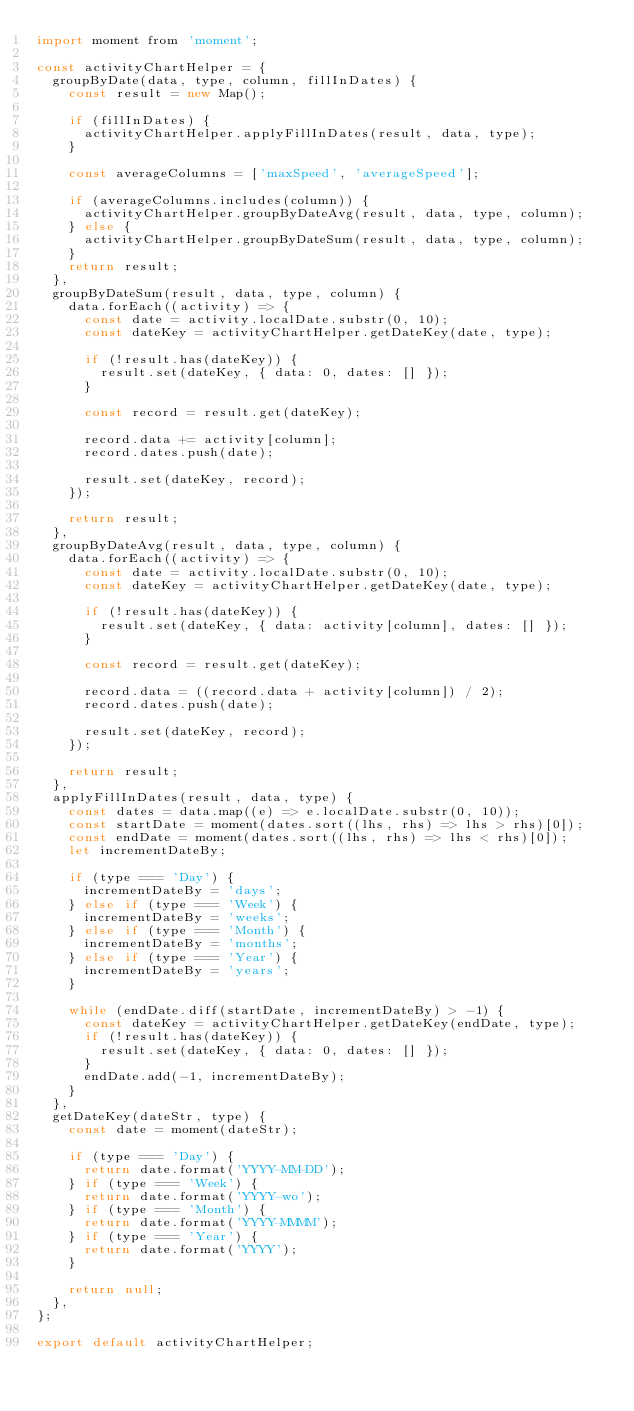Convert code to text. <code><loc_0><loc_0><loc_500><loc_500><_JavaScript_>import moment from 'moment';

const activityChartHelper = {
  groupByDate(data, type, column, fillInDates) {
    const result = new Map();

    if (fillInDates) {
      activityChartHelper.applyFillInDates(result, data, type);
    }

    const averageColumns = ['maxSpeed', 'averageSpeed'];

    if (averageColumns.includes(column)) {
      activityChartHelper.groupByDateAvg(result, data, type, column);
    } else {
      activityChartHelper.groupByDateSum(result, data, type, column);
    }
    return result;
  },
  groupByDateSum(result, data, type, column) {
    data.forEach((activity) => {
      const date = activity.localDate.substr(0, 10);
      const dateKey = activityChartHelper.getDateKey(date, type);

      if (!result.has(dateKey)) {
        result.set(dateKey, { data: 0, dates: [] });
      }

      const record = result.get(dateKey);

      record.data += activity[column];
      record.dates.push(date);

      result.set(dateKey, record);
    });

    return result;
  },
  groupByDateAvg(result, data, type, column) {
    data.forEach((activity) => {
      const date = activity.localDate.substr(0, 10);
      const dateKey = activityChartHelper.getDateKey(date, type);

      if (!result.has(dateKey)) {
        result.set(dateKey, { data: activity[column], dates: [] });
      }

      const record = result.get(dateKey);

      record.data = ((record.data + activity[column]) / 2);
      record.dates.push(date);

      result.set(dateKey, record);
    });

    return result;
  },
  applyFillInDates(result, data, type) {
    const dates = data.map((e) => e.localDate.substr(0, 10));
    const startDate = moment(dates.sort((lhs, rhs) => lhs > rhs)[0]);
    const endDate = moment(dates.sort((lhs, rhs) => lhs < rhs)[0]);
    let incrementDateBy;

    if (type === 'Day') {
      incrementDateBy = 'days';
    } else if (type === 'Week') {
      incrementDateBy = 'weeks';
    } else if (type === 'Month') {
      incrementDateBy = 'months';
    } else if (type === 'Year') {
      incrementDateBy = 'years';
    }

    while (endDate.diff(startDate, incrementDateBy) > -1) {
      const dateKey = activityChartHelper.getDateKey(endDate, type);
      if (!result.has(dateKey)) {
        result.set(dateKey, { data: 0, dates: [] });
      }
      endDate.add(-1, incrementDateBy);
    }
  },
  getDateKey(dateStr, type) {
    const date = moment(dateStr);

    if (type === 'Day') {
      return date.format('YYYY-MM-DD');
    } if (type === 'Week') {
      return date.format('YYYY-wo');
    } if (type === 'Month') {
      return date.format('YYYY-MMMM');
    } if (type === 'Year') {
      return date.format('YYYY');
    }

    return null;
  },
};

export default activityChartHelper;
</code> 